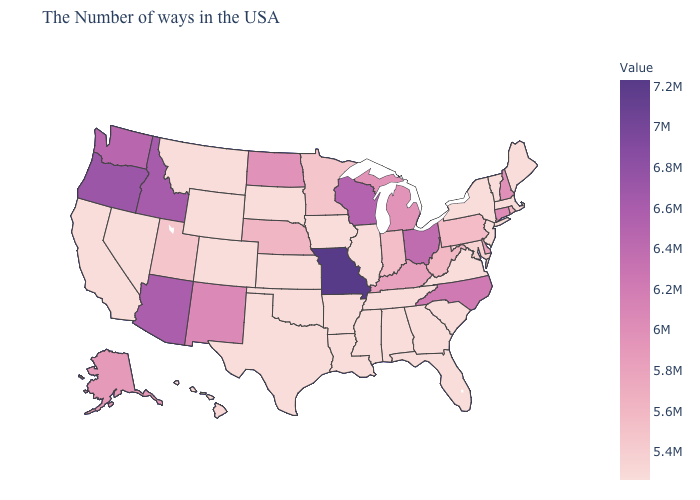Is the legend a continuous bar?
Keep it brief. Yes. Does California have a higher value than Connecticut?
Write a very short answer. No. 